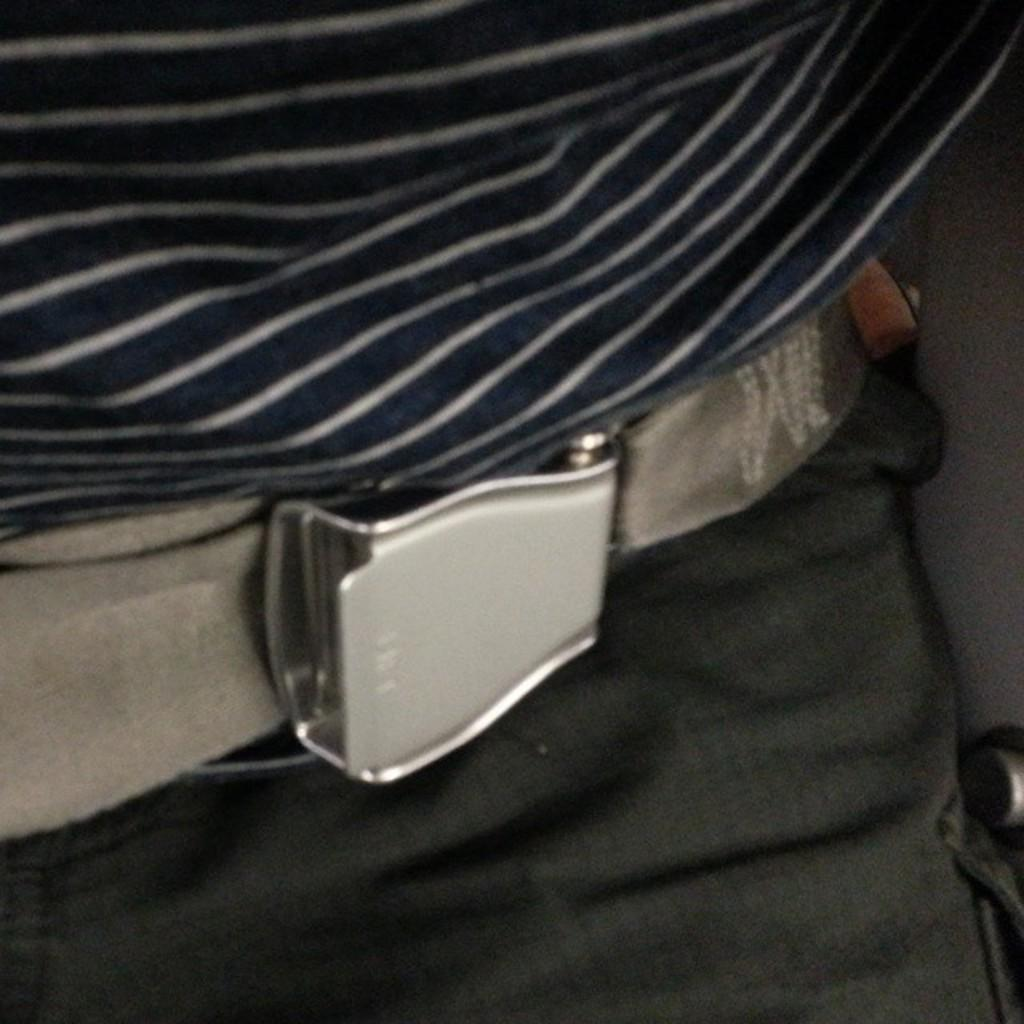What is the main subject in the center of the image? There is a belt in the center of the image. What month is depicted in the image? There is no month depicted in the image; it only features a belt. What type of beast is present in the image? There is no beast present in the image; it only features a belt. 